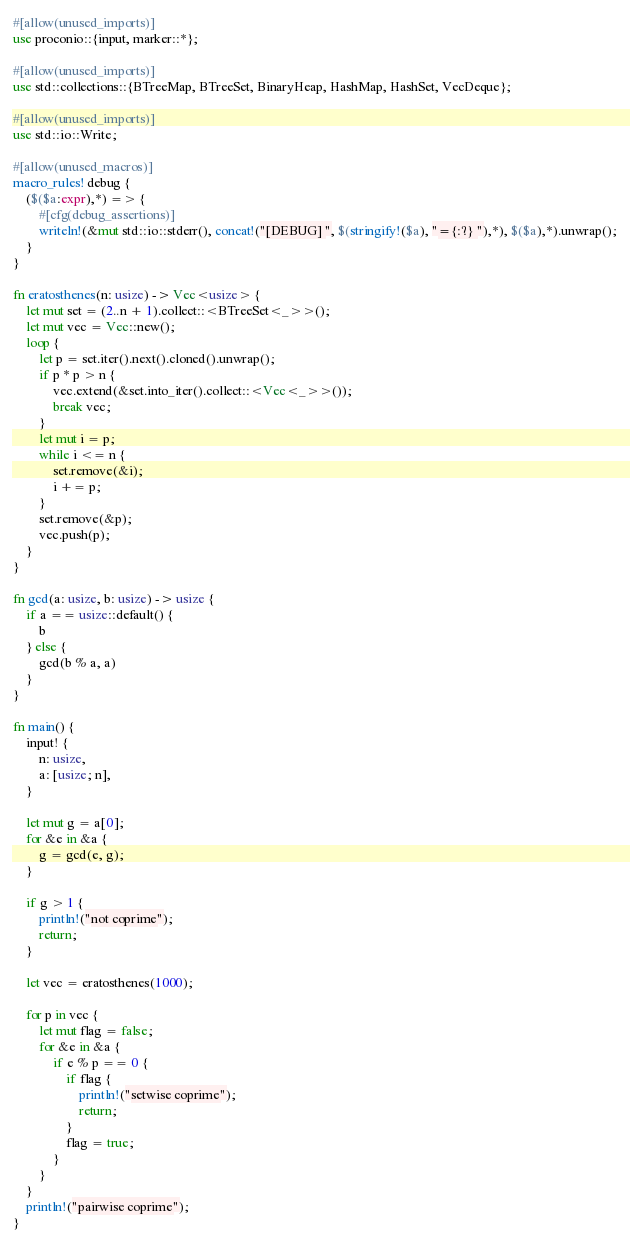Convert code to text. <code><loc_0><loc_0><loc_500><loc_500><_Rust_>#[allow(unused_imports)]
use proconio::{input, marker::*};

#[allow(unused_imports)]
use std::collections::{BTreeMap, BTreeSet, BinaryHeap, HashMap, HashSet, VecDeque};

#[allow(unused_imports)]
use std::io::Write;

#[allow(unused_macros)]
macro_rules! debug {
    ($($a:expr),*) => {
        #[cfg(debug_assertions)]
        writeln!(&mut std::io::stderr(), concat!("[DEBUG] ", $(stringify!($a), "={:?} "),*), $($a),*).unwrap();
    }
}

fn eratosthenes(n: usize) -> Vec<usize> {
    let mut set = (2..n + 1).collect::<BTreeSet<_>>();
    let mut vec = Vec::new();
    loop {
        let p = set.iter().next().cloned().unwrap();
        if p * p > n {
            vec.extend(&set.into_iter().collect::<Vec<_>>());
            break vec;
        }
        let mut i = p;
        while i <= n {
            set.remove(&i);
            i += p;
        }
        set.remove(&p);
        vec.push(p);
    }
}

fn gcd(a: usize, b: usize) -> usize {
    if a == usize::default() {
        b
    } else {
        gcd(b % a, a)
    }
}

fn main() {
    input! {
        n: usize,
        a: [usize; n],
    }

    let mut g = a[0];
    for &e in &a {
        g = gcd(e, g);
    }

    if g > 1 {
        println!("not coprime");
        return;
    }

    let vec = eratosthenes(1000);

    for p in vec {
        let mut flag = false;
        for &e in &a {
            if e % p == 0 {
                if flag {
                    println!("setwise coprime");
                    return;
                }
                flag = true;
            }
        }
    }
    println!("pairwise coprime");
}
</code> 